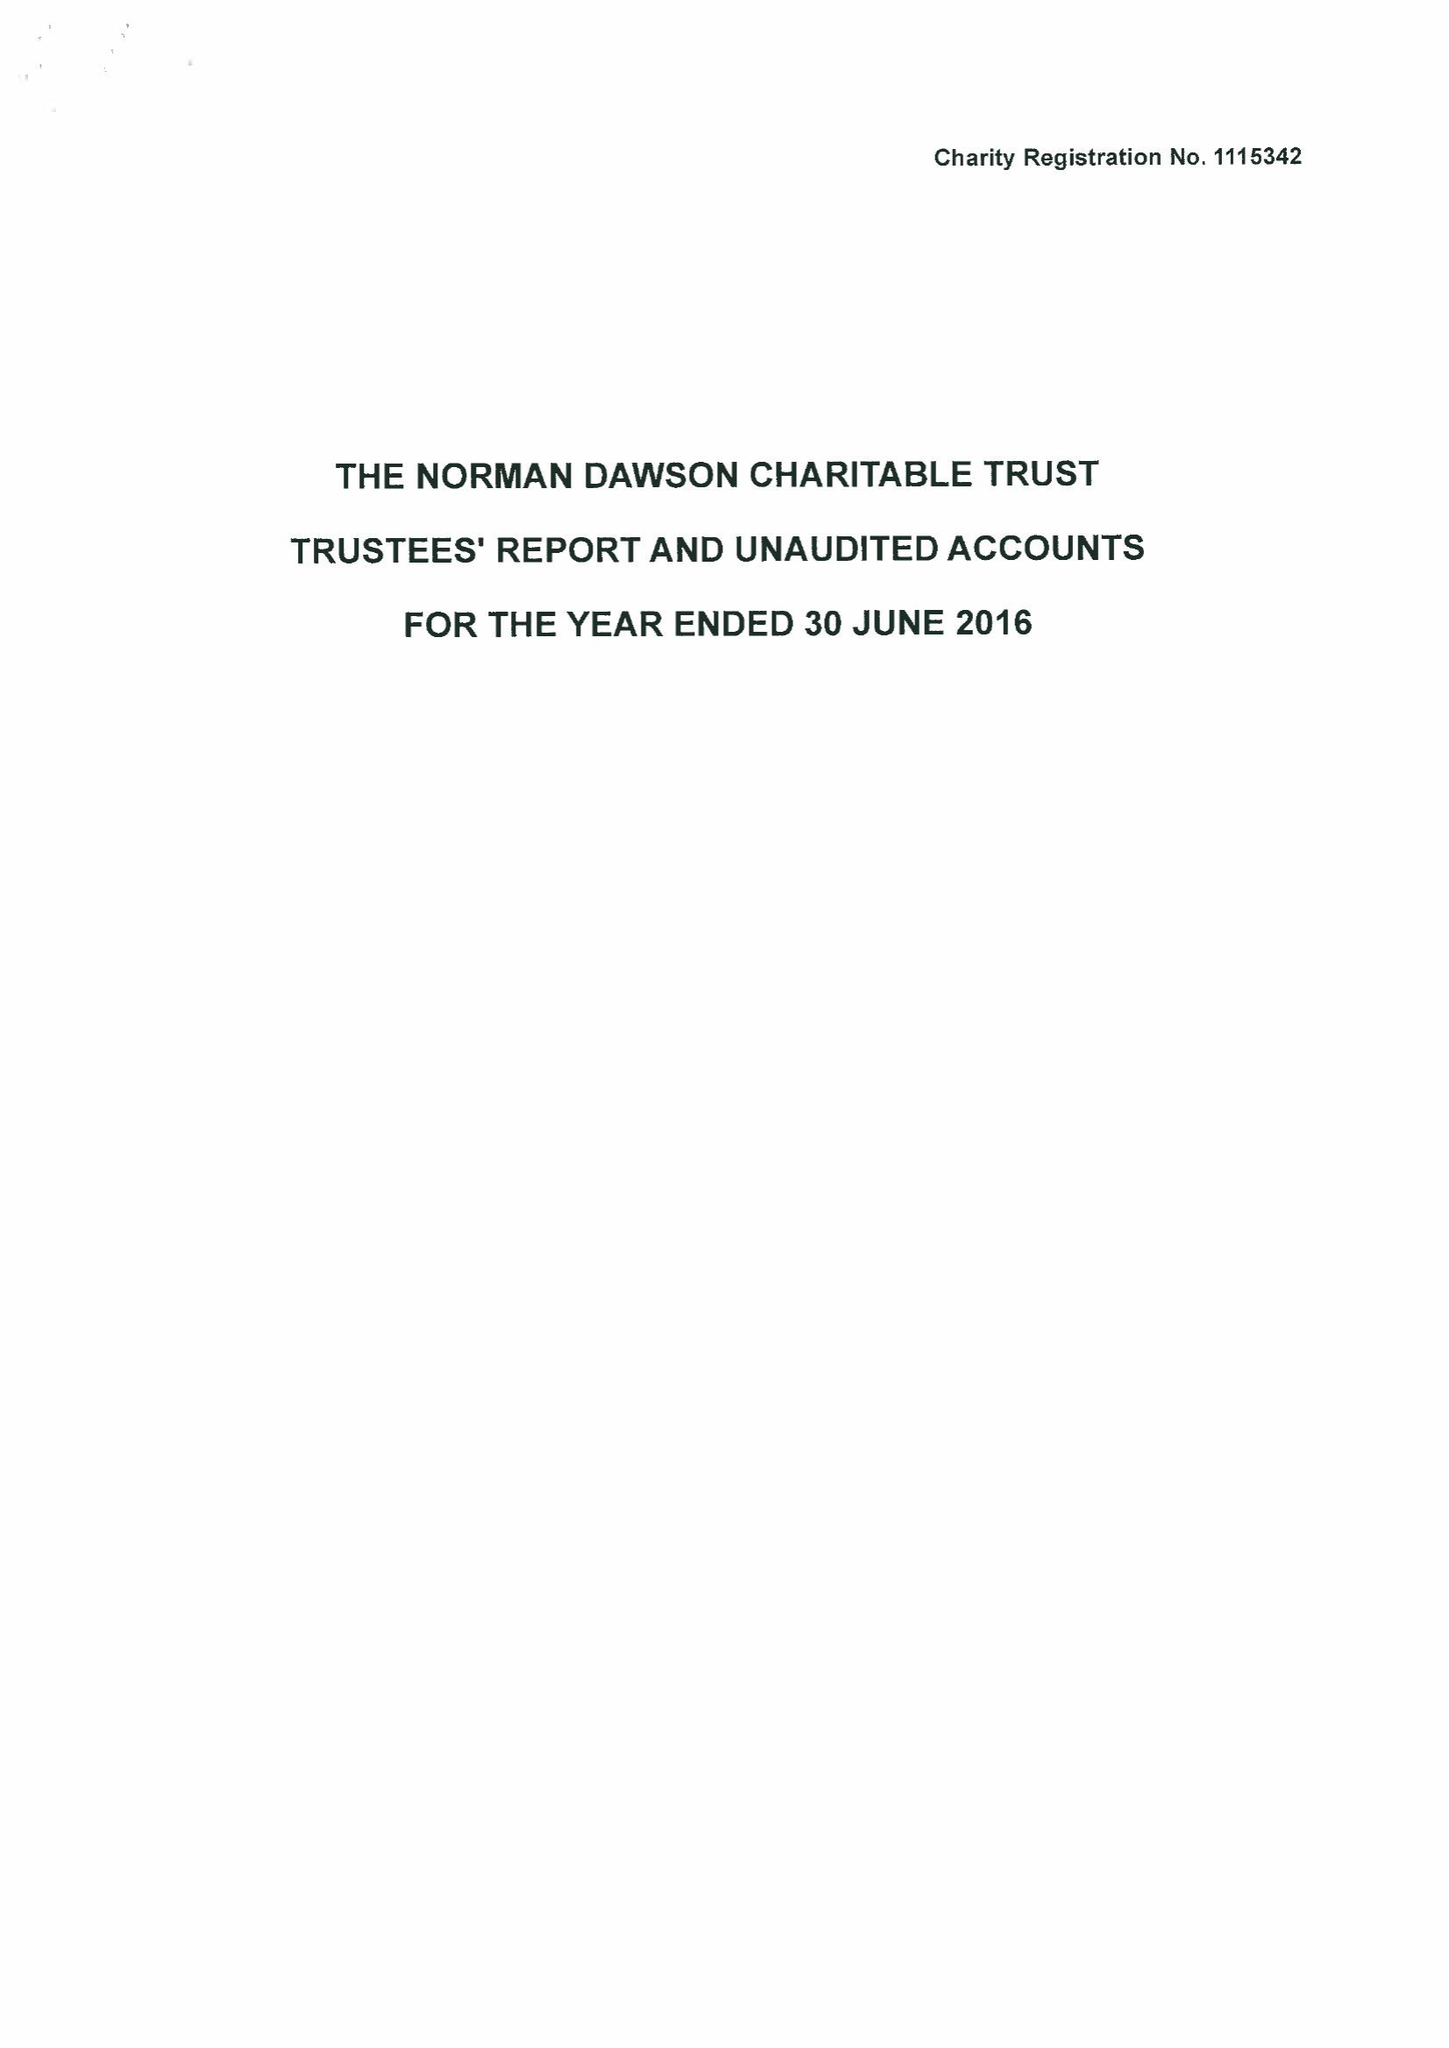What is the value for the address__street_line?
Answer the question using a single word or phrase. BIRMINGHAM ROAD 